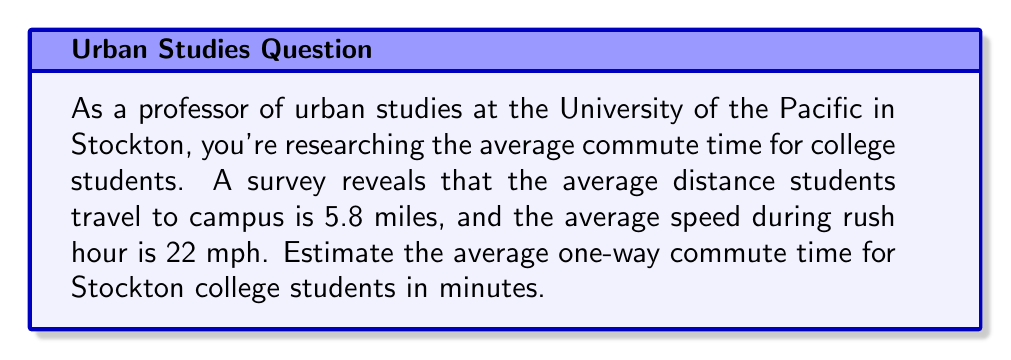Can you answer this question? To solve this problem, we'll use the formula:

$$ \text{Time} = \frac{\text{Distance}}{\text{Speed}} $$

Given:
- Average distance: 5.8 miles
- Average speed: 22 mph

Step 1: Plug the values into the formula
$$ \text{Time} = \frac{5.8 \text{ miles}}{22 \text{ mph}} $$

Step 2: Perform the division
$$ \text{Time} = 0.2636363636 \text{ hours} $$

Step 3: Convert hours to minutes
Multiply the result by 60 minutes/hour:
$$ 0.2636363636 \text{ hours} \times 60 \text{ minutes/hour} = 15.81818182 \text{ minutes} $$

Step 4: Round to a reasonable number of significant figures
Since we're estimating, we'll round to the nearest minute.
Answer: The estimated average one-way commute time for Stockton college students is approximately 16 minutes. 